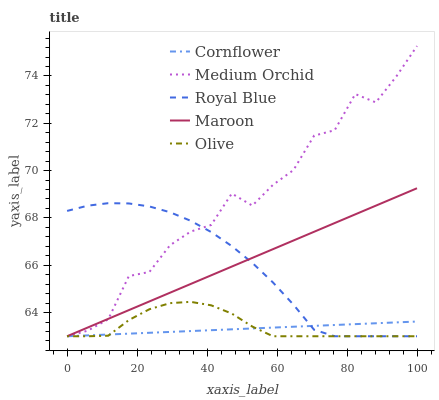Does Cornflower have the minimum area under the curve?
Answer yes or no. Yes. Does Medium Orchid have the maximum area under the curve?
Answer yes or no. Yes. Does Medium Orchid have the minimum area under the curve?
Answer yes or no. No. Does Cornflower have the maximum area under the curve?
Answer yes or no. No. Is Cornflower the smoothest?
Answer yes or no. Yes. Is Medium Orchid the roughest?
Answer yes or no. Yes. Is Medium Orchid the smoothest?
Answer yes or no. No. Is Cornflower the roughest?
Answer yes or no. No. Does Olive have the lowest value?
Answer yes or no. Yes. Does Medium Orchid have the highest value?
Answer yes or no. Yes. Does Cornflower have the highest value?
Answer yes or no. No. Does Medium Orchid intersect Maroon?
Answer yes or no. Yes. Is Medium Orchid less than Maroon?
Answer yes or no. No. Is Medium Orchid greater than Maroon?
Answer yes or no. No. 